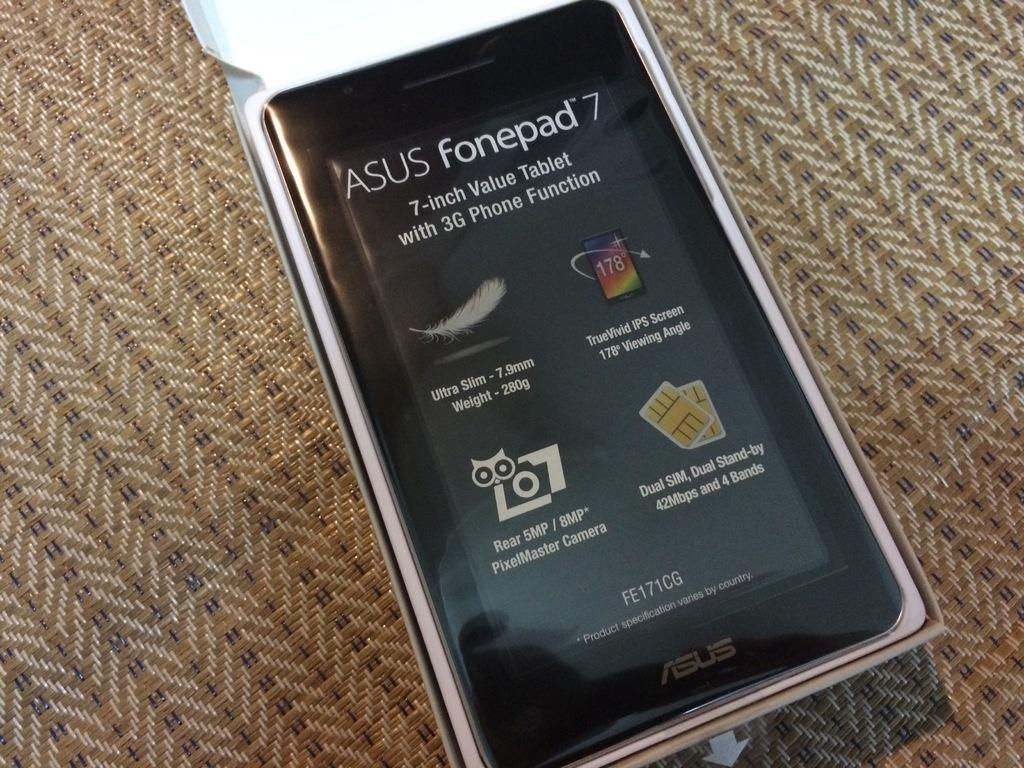<image>
Give a short and clear explanation of the subsequent image. a phone that has ASUS fonepad written on it 